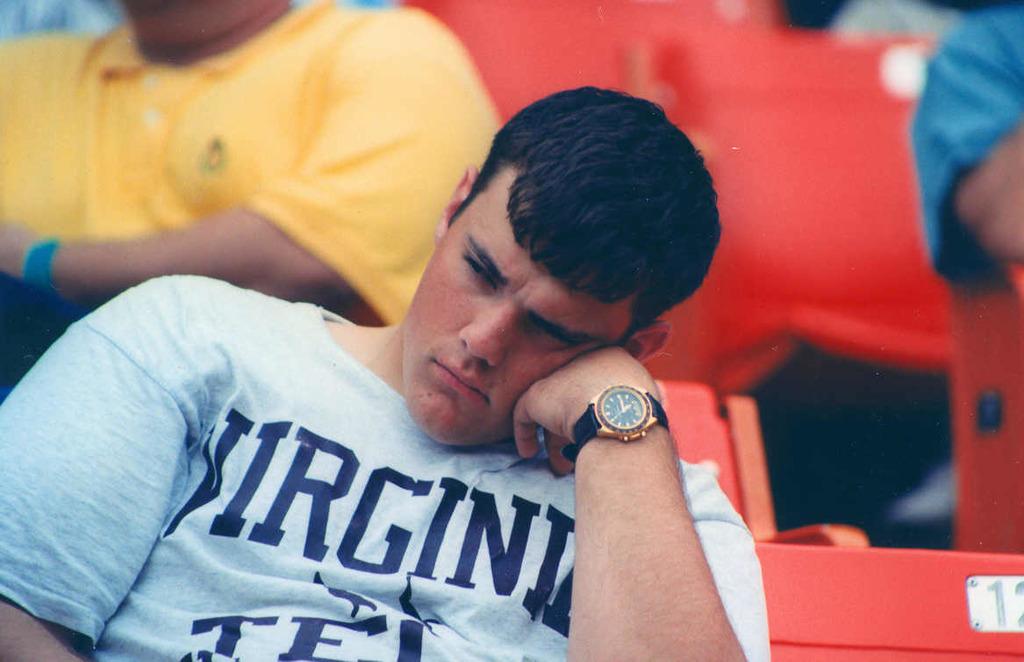What state does the blue shirt say?
Your response must be concise. Virginia. 